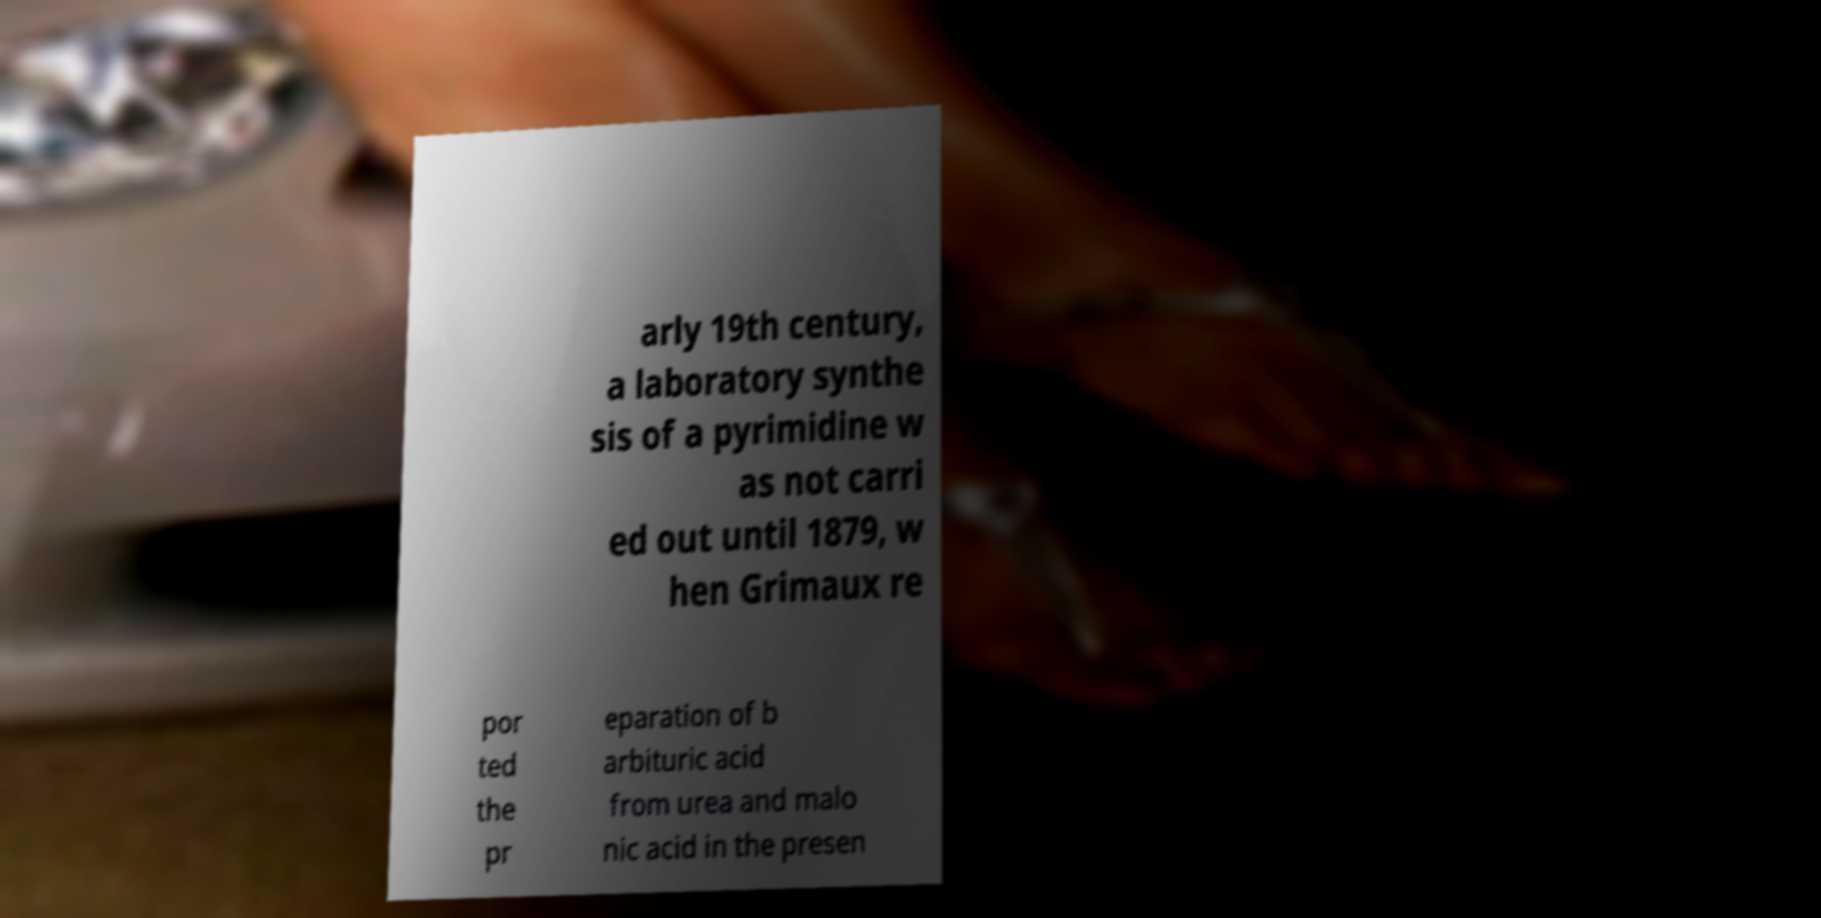I need the written content from this picture converted into text. Can you do that? arly 19th century, a laboratory synthe sis of a pyrimidine w as not carri ed out until 1879, w hen Grimaux re por ted the pr eparation of b arbituric acid from urea and malo nic acid in the presen 